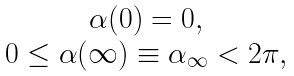Convert formula to latex. <formula><loc_0><loc_0><loc_500><loc_500>\begin{array} { c } \alpha ( 0 ) = 0 , \\ 0 \leq \alpha ( \infty ) \equiv \alpha _ { \infty } < 2 \pi , \end{array}</formula> 